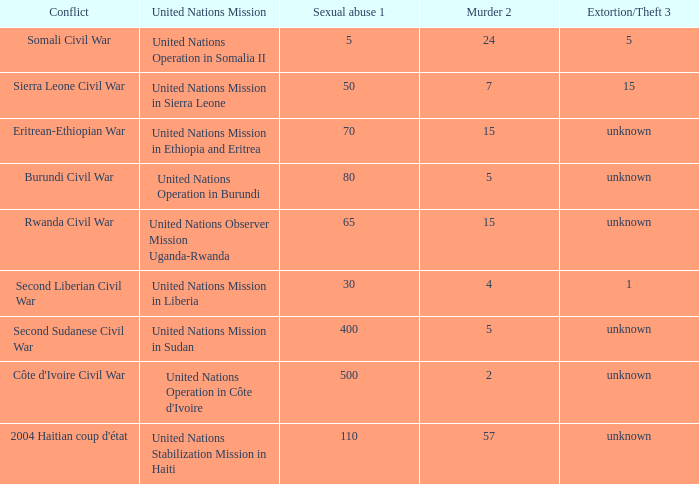What is the rate of exaction and larceny in regions with the presence of the united nations observer mission uganda-rwanda? Unknown. 